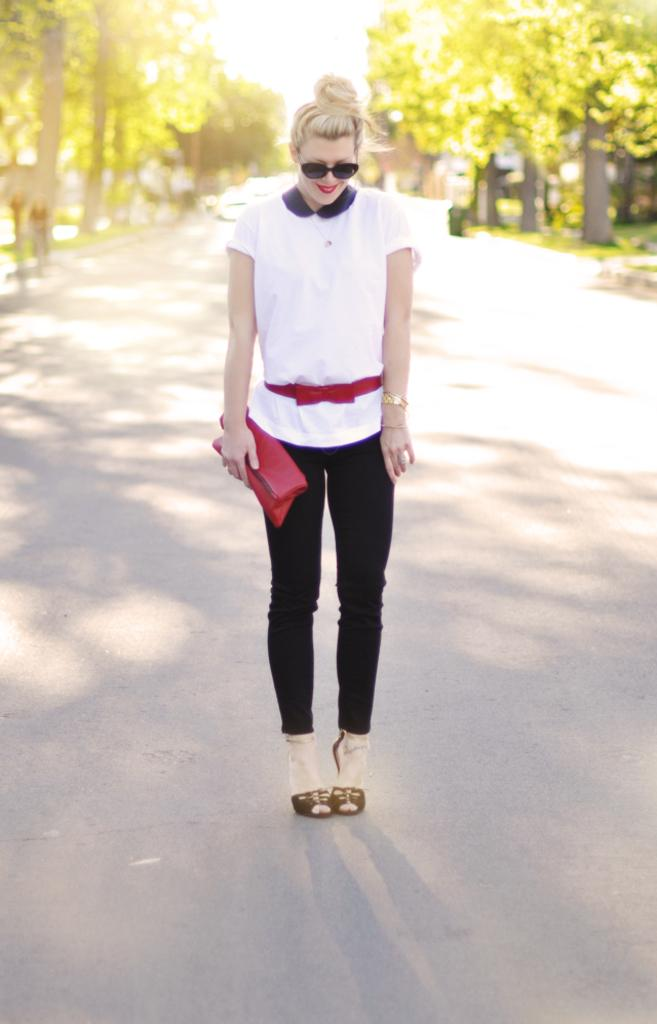What can be seen in the background of the image? There are trees in the background of the image. Who is present in the image? There is a woman in the image. What is the woman wearing on her face? The woman is wearing goggles. What is the woman holding in her hand? The woman is holding a purse. Where is the woman standing in the image? The woman is standing on the road. What is the woman's facial expression in the image? The woman is smiling. How many brothers does the woman have in the image? There is no information about the woman's brothers in the image. What type of ducks can be seen swimming in the background? There are no ducks present in the image; it features a woman standing on the road with trees in the background. 